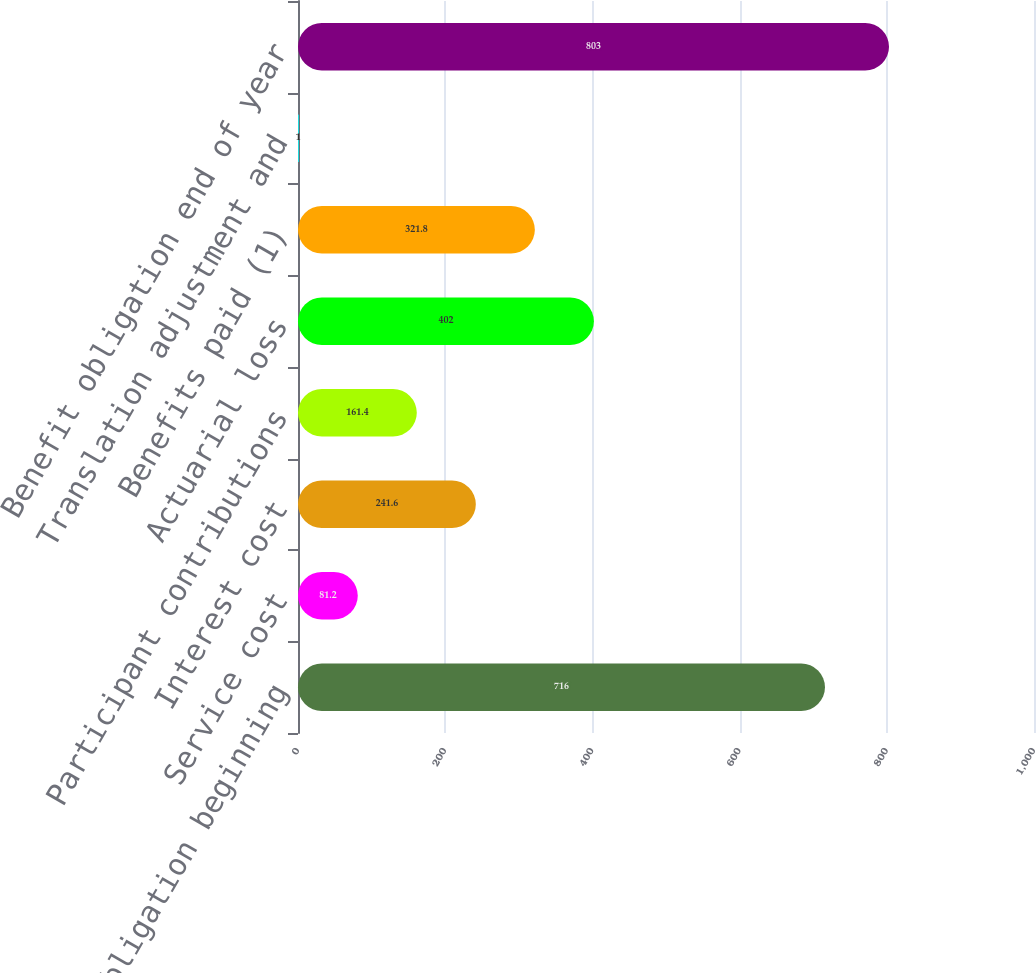<chart> <loc_0><loc_0><loc_500><loc_500><bar_chart><fcel>Benefit obligation beginning<fcel>Service cost<fcel>Interest cost<fcel>Participant contributions<fcel>Actuarial loss<fcel>Benefits paid (1)<fcel>Translation adjustment and<fcel>Benefit obligation end of year<nl><fcel>716<fcel>81.2<fcel>241.6<fcel>161.4<fcel>402<fcel>321.8<fcel>1<fcel>803<nl></chart> 